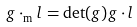Convert formula to latex. <formula><loc_0><loc_0><loc_500><loc_500>g \cdot _ { \text {m} } l = \det ( g ) g \cdot l</formula> 